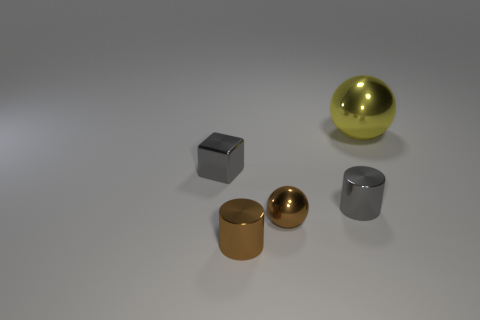Are there any tiny metallic objects that have the same color as the small cube?
Your answer should be compact. Yes. There is a small gray object on the left side of the gray cylinder; does it have the same shape as the gray metal thing on the right side of the brown metal cylinder?
Provide a short and direct response. No. What size is the shiny cylinder that is the same color as the tiny metallic ball?
Offer a very short reply. Small. How many other objects are the same size as the gray block?
Provide a succinct answer. 3. Does the tiny metal ball have the same color as the object that is right of the gray metallic cylinder?
Offer a terse response. No. Are there fewer tiny gray objects that are on the left side of the small brown cylinder than gray cubes right of the brown shiny sphere?
Provide a short and direct response. No. What color is the thing that is both on the right side of the tiny ball and in front of the big yellow thing?
Your answer should be compact. Gray. There is a gray cube; is it the same size as the shiny sphere left of the big yellow ball?
Your answer should be very brief. Yes. There is a gray thing in front of the gray metal cube; what shape is it?
Provide a succinct answer. Cylinder. Is the number of yellow shiny spheres behind the brown cylinder greater than the number of big yellow cubes?
Offer a very short reply. Yes. 